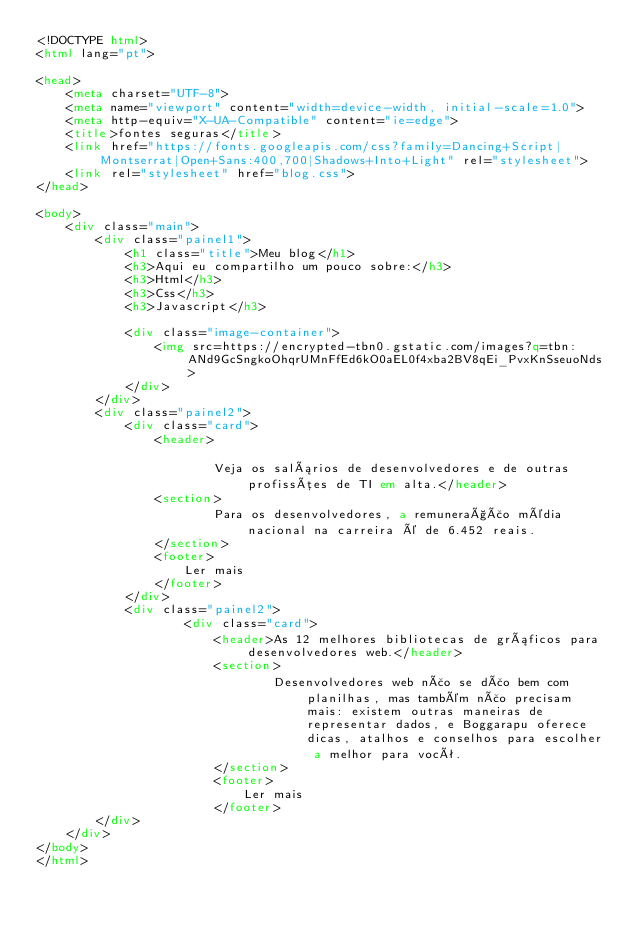<code> <loc_0><loc_0><loc_500><loc_500><_HTML_><!DOCTYPE html>
<html lang="pt">

<head>
    <meta charset="UTF-8">
    <meta name="viewport" content="width=device-width, initial-scale=1.0">
    <meta http-equiv="X-UA-Compatible" content="ie=edge">
    <title>fontes seguras</title>
    <link href="https://fonts.googleapis.com/css?family=Dancing+Script|Montserrat|Open+Sans:400,700|Shadows+Into+Light" rel="stylesheet">
    <link rel="stylesheet" href="blog.css">
</head>

<body>
    <div class="main">
        <div class="painel1">
            <h1 class="title">Meu blog</h1>
            <h3>Aqui eu compartilho um pouco sobre:</h3>
            <h3>Html</h3>
            <h3>Css</h3>
            <h3>Javascript</h3>

            <div class="image-container">
                <img src=https://encrypted-tbn0.gstatic.com/images?q=tbn:ANd9GcSngkoOhqrUMnFfEd6kO0aEL0f4xba2BV8qEi_PvxKnSseuoNds>
            </div> 
        </div> 
        <div class="painel2">
            <div class="card">
                <header>
                    
                        Veja os salários de desenvolvedores e de outras profissões de TI em alta.</header>
                <section>
                        Para os desenvolvedores, a remuneração média nacional na carreira é de 6.452 reais. 
                </section>
                <footer>
                    Ler mais
                </footer>
            </div>
            <div class="painel2">
                    <div class="card">
                        <header>As 12 melhores bibliotecas de gráficos para desenvolvedores web.</header>
                        <section>
                                Desenvolvedores web não se dão bem com planilhas, mas também não precisam mais: existem outras maneiras de representar dados, e Boggarapu oferece dicas, atalhos e conselhos para escolher a melhor para você.
                        </section>
                        <footer>
                            Ler mais
                        </footer>
        </div>
    </div> 
</body>
</html></code> 